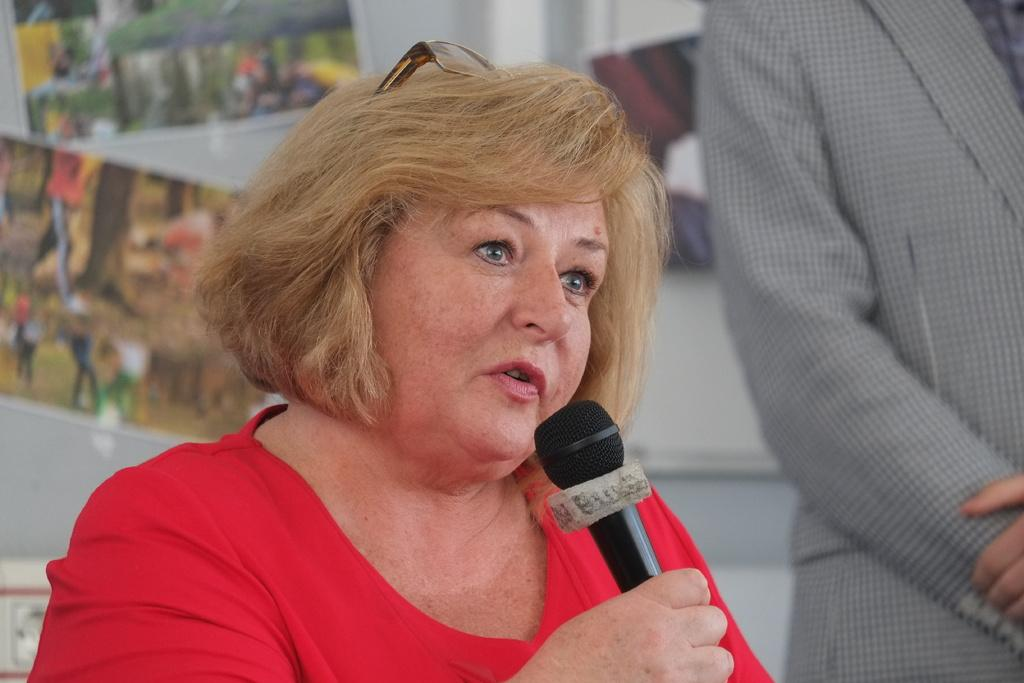Who is the main subject in the image? There is a woman in the image. What is the woman holding in her hand? The woman is holding a microphone in her hand. What advice is the woman giving to the person in jail in the image? There is no person in jail or any indication of advice-giving in the image; it only shows a woman holding a microphone. 